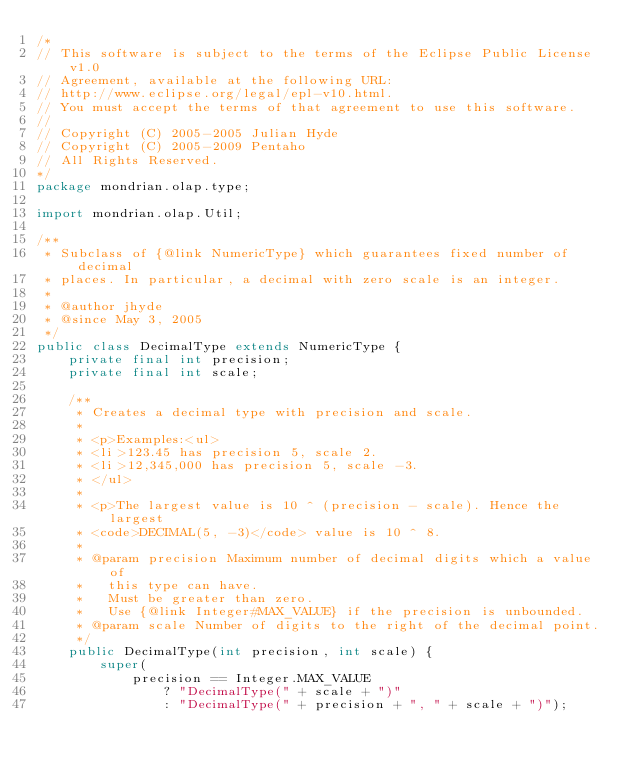<code> <loc_0><loc_0><loc_500><loc_500><_Java_>/*
// This software is subject to the terms of the Eclipse Public License v1.0
// Agreement, available at the following URL:
// http://www.eclipse.org/legal/epl-v10.html.
// You must accept the terms of that agreement to use this software.
//
// Copyright (C) 2005-2005 Julian Hyde
// Copyright (C) 2005-2009 Pentaho
// All Rights Reserved.
*/
package mondrian.olap.type;

import mondrian.olap.Util;

/**
 * Subclass of {@link NumericType} which guarantees fixed number of decimal
 * places. In particular, a decimal with zero scale is an integer.
 *
 * @author jhyde
 * @since May 3, 2005
 */
public class DecimalType extends NumericType {
    private final int precision;
    private final int scale;

    /**
     * Creates a decimal type with precision and scale.
     *
     * <p>Examples:<ul>
     * <li>123.45 has precision 5, scale 2.
     * <li>12,345,000 has precision 5, scale -3.
     * </ul>
     *
     * <p>The largest value is 10 ^ (precision - scale). Hence the largest
     * <code>DECIMAL(5, -3)</code> value is 10 ^ 8.
     *
     * @param precision Maximum number of decimal digits which a value of
     *   this type can have.
     *   Must be greater than zero.
     *   Use {@link Integer#MAX_VALUE} if the precision is unbounded.
     * @param scale Number of digits to the right of the decimal point.
     */
    public DecimalType(int precision, int scale) {
        super(
            precision == Integer.MAX_VALUE
                ? "DecimalType(" + scale + ")"
                : "DecimalType(" + precision + ", " + scale + ")");</code> 